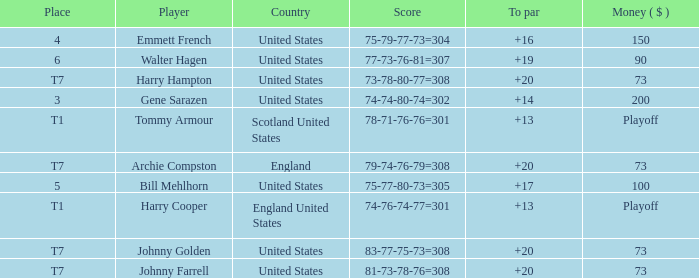Which country has a to par less than 19 and a score of 75-79-77-73=304? United States. 